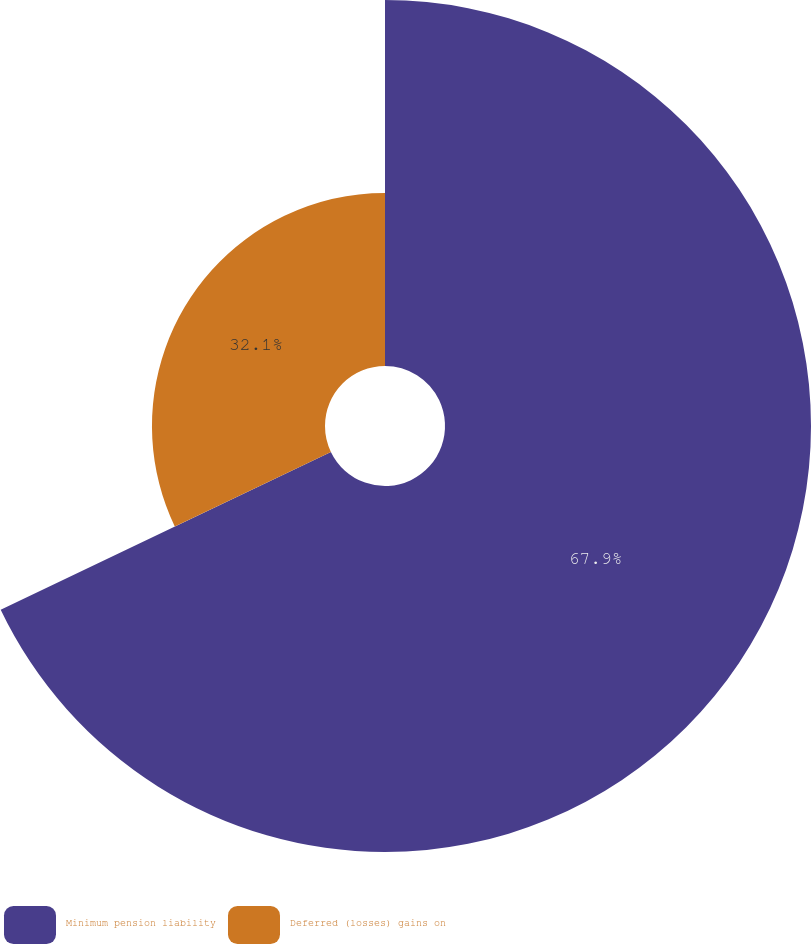<chart> <loc_0><loc_0><loc_500><loc_500><pie_chart><fcel>Minimum pension liability<fcel>Deferred (losses) gains on<nl><fcel>67.9%<fcel>32.1%<nl></chart> 